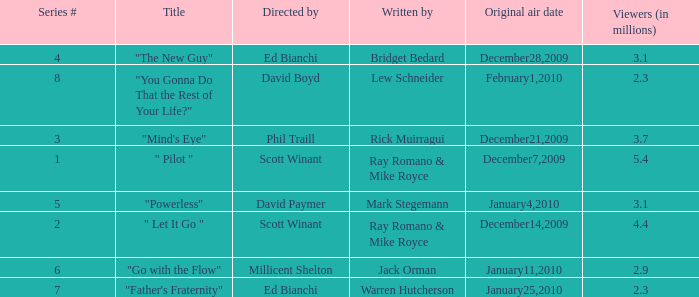When did the episode  "you gonna do that the rest of your life?" air? February1,2010. 